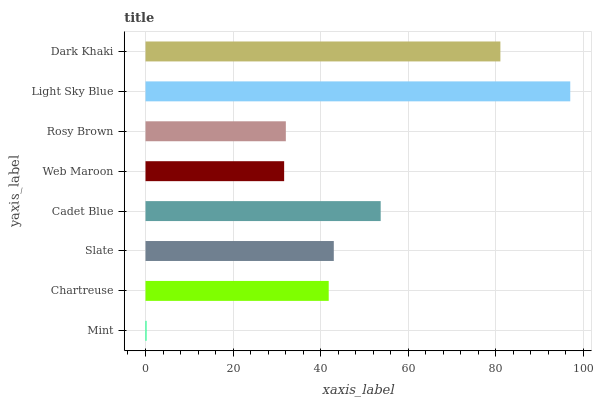Is Mint the minimum?
Answer yes or no. Yes. Is Light Sky Blue the maximum?
Answer yes or no. Yes. Is Chartreuse the minimum?
Answer yes or no. No. Is Chartreuse the maximum?
Answer yes or no. No. Is Chartreuse greater than Mint?
Answer yes or no. Yes. Is Mint less than Chartreuse?
Answer yes or no. Yes. Is Mint greater than Chartreuse?
Answer yes or no. No. Is Chartreuse less than Mint?
Answer yes or no. No. Is Slate the high median?
Answer yes or no. Yes. Is Chartreuse the low median?
Answer yes or no. Yes. Is Mint the high median?
Answer yes or no. No. Is Cadet Blue the low median?
Answer yes or no. No. 